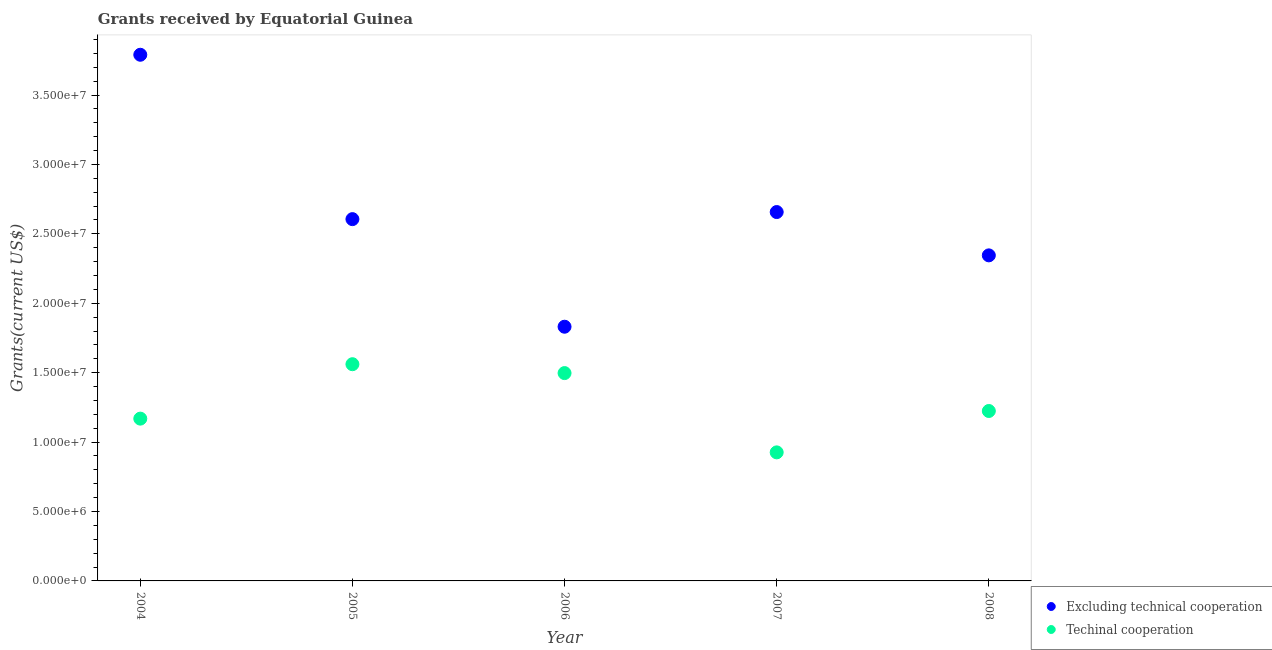How many different coloured dotlines are there?
Offer a terse response. 2. What is the amount of grants received(including technical cooperation) in 2008?
Keep it short and to the point. 1.22e+07. Across all years, what is the maximum amount of grants received(including technical cooperation)?
Make the answer very short. 1.56e+07. Across all years, what is the minimum amount of grants received(excluding technical cooperation)?
Your response must be concise. 1.83e+07. In which year was the amount of grants received(excluding technical cooperation) maximum?
Offer a very short reply. 2004. In which year was the amount of grants received(including technical cooperation) minimum?
Ensure brevity in your answer.  2007. What is the total amount of grants received(excluding technical cooperation) in the graph?
Give a very brief answer. 1.32e+08. What is the difference between the amount of grants received(including technical cooperation) in 2005 and that in 2006?
Ensure brevity in your answer.  6.40e+05. What is the difference between the amount of grants received(including technical cooperation) in 2007 and the amount of grants received(excluding technical cooperation) in 2008?
Offer a terse response. -1.42e+07. What is the average amount of grants received(excluding technical cooperation) per year?
Make the answer very short. 2.65e+07. In the year 2004, what is the difference between the amount of grants received(including technical cooperation) and amount of grants received(excluding technical cooperation)?
Offer a very short reply. -2.62e+07. In how many years, is the amount of grants received(including technical cooperation) greater than 2000000 US$?
Offer a very short reply. 5. What is the ratio of the amount of grants received(excluding technical cooperation) in 2004 to that in 2006?
Give a very brief answer. 2.07. Is the amount of grants received(including technical cooperation) in 2004 less than that in 2005?
Offer a terse response. Yes. Is the difference between the amount of grants received(including technical cooperation) in 2006 and 2008 greater than the difference between the amount of grants received(excluding technical cooperation) in 2006 and 2008?
Your response must be concise. Yes. What is the difference between the highest and the second highest amount of grants received(excluding technical cooperation)?
Your response must be concise. 1.13e+07. What is the difference between the highest and the lowest amount of grants received(including technical cooperation)?
Offer a terse response. 6.35e+06. Is the sum of the amount of grants received(including technical cooperation) in 2004 and 2006 greater than the maximum amount of grants received(excluding technical cooperation) across all years?
Make the answer very short. No. Is the amount of grants received(including technical cooperation) strictly less than the amount of grants received(excluding technical cooperation) over the years?
Your answer should be compact. Yes. How many dotlines are there?
Ensure brevity in your answer.  2. What is the difference between two consecutive major ticks on the Y-axis?
Offer a terse response. 5.00e+06. What is the title of the graph?
Provide a short and direct response. Grants received by Equatorial Guinea. Does "Mineral" appear as one of the legend labels in the graph?
Offer a very short reply. No. What is the label or title of the X-axis?
Make the answer very short. Year. What is the label or title of the Y-axis?
Your answer should be compact. Grants(current US$). What is the Grants(current US$) of Excluding technical cooperation in 2004?
Offer a terse response. 3.79e+07. What is the Grants(current US$) in Techinal cooperation in 2004?
Provide a succinct answer. 1.17e+07. What is the Grants(current US$) of Excluding technical cooperation in 2005?
Make the answer very short. 2.61e+07. What is the Grants(current US$) in Techinal cooperation in 2005?
Your response must be concise. 1.56e+07. What is the Grants(current US$) in Excluding technical cooperation in 2006?
Offer a terse response. 1.83e+07. What is the Grants(current US$) in Techinal cooperation in 2006?
Offer a very short reply. 1.50e+07. What is the Grants(current US$) in Excluding technical cooperation in 2007?
Make the answer very short. 2.66e+07. What is the Grants(current US$) of Techinal cooperation in 2007?
Give a very brief answer. 9.26e+06. What is the Grants(current US$) in Excluding technical cooperation in 2008?
Provide a succinct answer. 2.34e+07. What is the Grants(current US$) in Techinal cooperation in 2008?
Provide a succinct answer. 1.22e+07. Across all years, what is the maximum Grants(current US$) in Excluding technical cooperation?
Provide a succinct answer. 3.79e+07. Across all years, what is the maximum Grants(current US$) in Techinal cooperation?
Your response must be concise. 1.56e+07. Across all years, what is the minimum Grants(current US$) of Excluding technical cooperation?
Offer a terse response. 1.83e+07. Across all years, what is the minimum Grants(current US$) of Techinal cooperation?
Make the answer very short. 9.26e+06. What is the total Grants(current US$) in Excluding technical cooperation in the graph?
Keep it short and to the point. 1.32e+08. What is the total Grants(current US$) of Techinal cooperation in the graph?
Your answer should be compact. 6.38e+07. What is the difference between the Grants(current US$) of Excluding technical cooperation in 2004 and that in 2005?
Give a very brief answer. 1.18e+07. What is the difference between the Grants(current US$) in Techinal cooperation in 2004 and that in 2005?
Give a very brief answer. -3.92e+06. What is the difference between the Grants(current US$) in Excluding technical cooperation in 2004 and that in 2006?
Provide a succinct answer. 1.96e+07. What is the difference between the Grants(current US$) in Techinal cooperation in 2004 and that in 2006?
Your answer should be very brief. -3.28e+06. What is the difference between the Grants(current US$) in Excluding technical cooperation in 2004 and that in 2007?
Give a very brief answer. 1.13e+07. What is the difference between the Grants(current US$) in Techinal cooperation in 2004 and that in 2007?
Your answer should be very brief. 2.43e+06. What is the difference between the Grants(current US$) of Excluding technical cooperation in 2004 and that in 2008?
Keep it short and to the point. 1.44e+07. What is the difference between the Grants(current US$) in Techinal cooperation in 2004 and that in 2008?
Provide a succinct answer. -5.50e+05. What is the difference between the Grants(current US$) of Excluding technical cooperation in 2005 and that in 2006?
Keep it short and to the point. 7.75e+06. What is the difference between the Grants(current US$) in Techinal cooperation in 2005 and that in 2006?
Ensure brevity in your answer.  6.40e+05. What is the difference between the Grants(current US$) of Excluding technical cooperation in 2005 and that in 2007?
Give a very brief answer. -5.10e+05. What is the difference between the Grants(current US$) in Techinal cooperation in 2005 and that in 2007?
Make the answer very short. 6.35e+06. What is the difference between the Grants(current US$) of Excluding technical cooperation in 2005 and that in 2008?
Your answer should be compact. 2.61e+06. What is the difference between the Grants(current US$) in Techinal cooperation in 2005 and that in 2008?
Your answer should be compact. 3.37e+06. What is the difference between the Grants(current US$) of Excluding technical cooperation in 2006 and that in 2007?
Your answer should be compact. -8.26e+06. What is the difference between the Grants(current US$) of Techinal cooperation in 2006 and that in 2007?
Provide a succinct answer. 5.71e+06. What is the difference between the Grants(current US$) of Excluding technical cooperation in 2006 and that in 2008?
Your answer should be compact. -5.14e+06. What is the difference between the Grants(current US$) in Techinal cooperation in 2006 and that in 2008?
Your response must be concise. 2.73e+06. What is the difference between the Grants(current US$) in Excluding technical cooperation in 2007 and that in 2008?
Your response must be concise. 3.12e+06. What is the difference between the Grants(current US$) in Techinal cooperation in 2007 and that in 2008?
Make the answer very short. -2.98e+06. What is the difference between the Grants(current US$) of Excluding technical cooperation in 2004 and the Grants(current US$) of Techinal cooperation in 2005?
Keep it short and to the point. 2.23e+07. What is the difference between the Grants(current US$) in Excluding technical cooperation in 2004 and the Grants(current US$) in Techinal cooperation in 2006?
Provide a succinct answer. 2.29e+07. What is the difference between the Grants(current US$) of Excluding technical cooperation in 2004 and the Grants(current US$) of Techinal cooperation in 2007?
Ensure brevity in your answer.  2.86e+07. What is the difference between the Grants(current US$) of Excluding technical cooperation in 2004 and the Grants(current US$) of Techinal cooperation in 2008?
Offer a very short reply. 2.57e+07. What is the difference between the Grants(current US$) of Excluding technical cooperation in 2005 and the Grants(current US$) of Techinal cooperation in 2006?
Provide a succinct answer. 1.11e+07. What is the difference between the Grants(current US$) in Excluding technical cooperation in 2005 and the Grants(current US$) in Techinal cooperation in 2007?
Your answer should be compact. 1.68e+07. What is the difference between the Grants(current US$) of Excluding technical cooperation in 2005 and the Grants(current US$) of Techinal cooperation in 2008?
Offer a very short reply. 1.38e+07. What is the difference between the Grants(current US$) of Excluding technical cooperation in 2006 and the Grants(current US$) of Techinal cooperation in 2007?
Your answer should be compact. 9.05e+06. What is the difference between the Grants(current US$) of Excluding technical cooperation in 2006 and the Grants(current US$) of Techinal cooperation in 2008?
Ensure brevity in your answer.  6.07e+06. What is the difference between the Grants(current US$) of Excluding technical cooperation in 2007 and the Grants(current US$) of Techinal cooperation in 2008?
Your answer should be very brief. 1.43e+07. What is the average Grants(current US$) of Excluding technical cooperation per year?
Your answer should be very brief. 2.65e+07. What is the average Grants(current US$) in Techinal cooperation per year?
Keep it short and to the point. 1.28e+07. In the year 2004, what is the difference between the Grants(current US$) of Excluding technical cooperation and Grants(current US$) of Techinal cooperation?
Offer a terse response. 2.62e+07. In the year 2005, what is the difference between the Grants(current US$) in Excluding technical cooperation and Grants(current US$) in Techinal cooperation?
Ensure brevity in your answer.  1.04e+07. In the year 2006, what is the difference between the Grants(current US$) of Excluding technical cooperation and Grants(current US$) of Techinal cooperation?
Keep it short and to the point. 3.34e+06. In the year 2007, what is the difference between the Grants(current US$) in Excluding technical cooperation and Grants(current US$) in Techinal cooperation?
Your answer should be very brief. 1.73e+07. In the year 2008, what is the difference between the Grants(current US$) of Excluding technical cooperation and Grants(current US$) of Techinal cooperation?
Provide a short and direct response. 1.12e+07. What is the ratio of the Grants(current US$) in Excluding technical cooperation in 2004 to that in 2005?
Keep it short and to the point. 1.45. What is the ratio of the Grants(current US$) in Techinal cooperation in 2004 to that in 2005?
Your response must be concise. 0.75. What is the ratio of the Grants(current US$) of Excluding technical cooperation in 2004 to that in 2006?
Ensure brevity in your answer.  2.07. What is the ratio of the Grants(current US$) of Techinal cooperation in 2004 to that in 2006?
Offer a very short reply. 0.78. What is the ratio of the Grants(current US$) in Excluding technical cooperation in 2004 to that in 2007?
Offer a terse response. 1.43. What is the ratio of the Grants(current US$) of Techinal cooperation in 2004 to that in 2007?
Keep it short and to the point. 1.26. What is the ratio of the Grants(current US$) of Excluding technical cooperation in 2004 to that in 2008?
Provide a short and direct response. 1.62. What is the ratio of the Grants(current US$) in Techinal cooperation in 2004 to that in 2008?
Make the answer very short. 0.96. What is the ratio of the Grants(current US$) of Excluding technical cooperation in 2005 to that in 2006?
Your response must be concise. 1.42. What is the ratio of the Grants(current US$) in Techinal cooperation in 2005 to that in 2006?
Provide a short and direct response. 1.04. What is the ratio of the Grants(current US$) of Excluding technical cooperation in 2005 to that in 2007?
Make the answer very short. 0.98. What is the ratio of the Grants(current US$) in Techinal cooperation in 2005 to that in 2007?
Your answer should be compact. 1.69. What is the ratio of the Grants(current US$) of Excluding technical cooperation in 2005 to that in 2008?
Offer a terse response. 1.11. What is the ratio of the Grants(current US$) in Techinal cooperation in 2005 to that in 2008?
Your answer should be compact. 1.28. What is the ratio of the Grants(current US$) in Excluding technical cooperation in 2006 to that in 2007?
Your answer should be compact. 0.69. What is the ratio of the Grants(current US$) in Techinal cooperation in 2006 to that in 2007?
Provide a short and direct response. 1.62. What is the ratio of the Grants(current US$) of Excluding technical cooperation in 2006 to that in 2008?
Provide a short and direct response. 0.78. What is the ratio of the Grants(current US$) in Techinal cooperation in 2006 to that in 2008?
Give a very brief answer. 1.22. What is the ratio of the Grants(current US$) in Excluding technical cooperation in 2007 to that in 2008?
Offer a terse response. 1.13. What is the ratio of the Grants(current US$) of Techinal cooperation in 2007 to that in 2008?
Give a very brief answer. 0.76. What is the difference between the highest and the second highest Grants(current US$) of Excluding technical cooperation?
Give a very brief answer. 1.13e+07. What is the difference between the highest and the second highest Grants(current US$) in Techinal cooperation?
Your answer should be very brief. 6.40e+05. What is the difference between the highest and the lowest Grants(current US$) of Excluding technical cooperation?
Ensure brevity in your answer.  1.96e+07. What is the difference between the highest and the lowest Grants(current US$) of Techinal cooperation?
Give a very brief answer. 6.35e+06. 